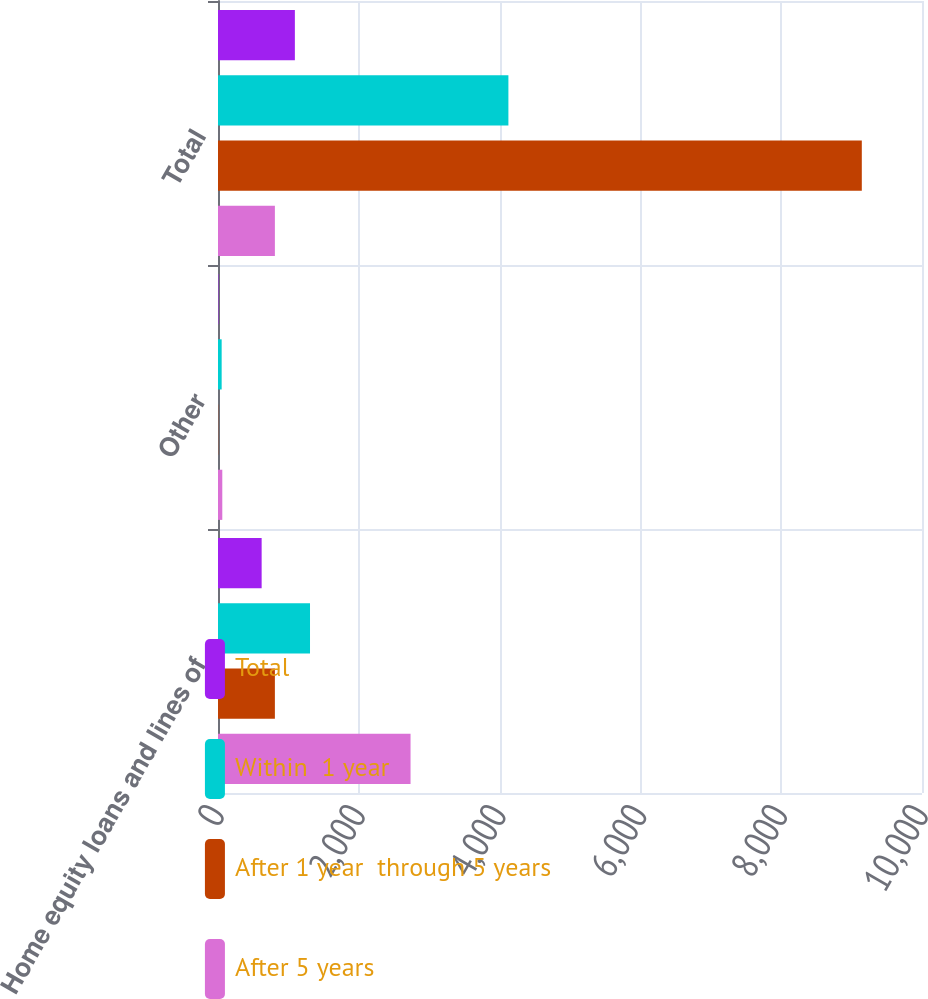Convert chart to OTSL. <chart><loc_0><loc_0><loc_500><loc_500><stacked_bar_chart><ecel><fcel>Home equity loans and lines of<fcel>Other<fcel>Total<nl><fcel>Total<fcel>620<fcel>6<fcel>1092<nl><fcel>Within  1 year<fcel>1307<fcel>52<fcel>4125<nl><fcel>After 1 year  through 5 years<fcel>808<fcel>3<fcel>9145<nl><fcel>After 5 years<fcel>2735<fcel>61<fcel>808<nl></chart> 